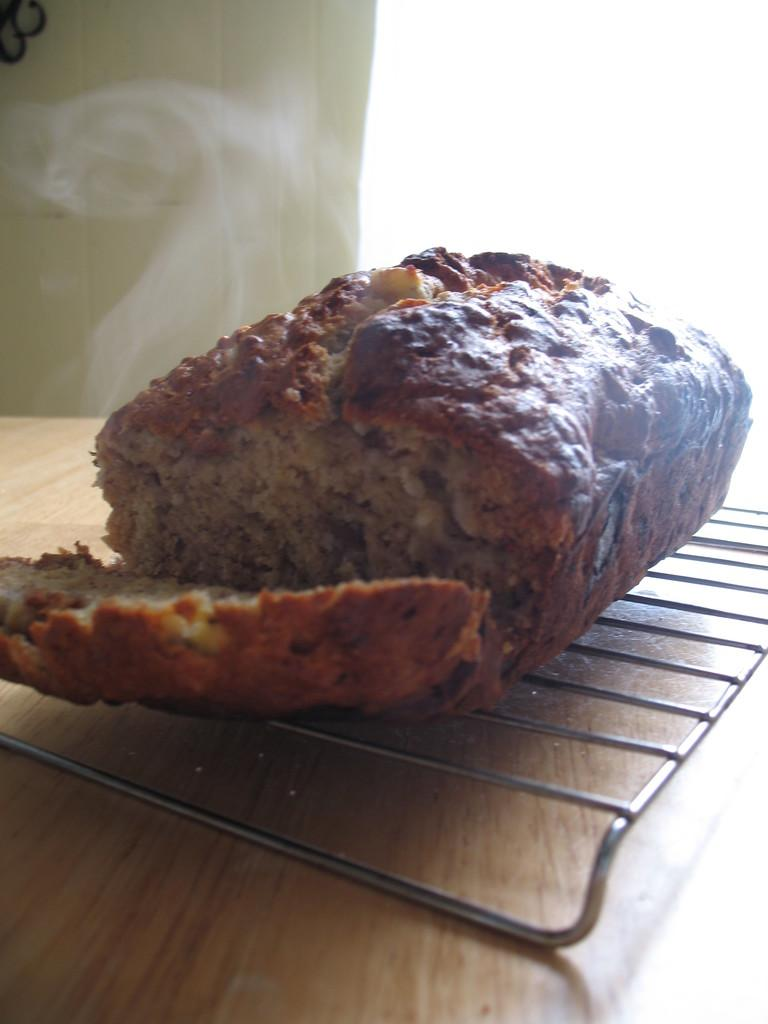What type of surface is visible in the image? There is a wooden surface in the image. What is being cooked on the wooden surface? Food is present on grills in the image. What can be seen in the background of the image? There is a wall in the background of the image. What type of spy equipment can be seen on the wooden surface in the image? There is no spy equipment present in the image; it features a wooden surface with food on grills. What type of collar is visible on the food in the image? There is no collar present on the food in the image; it is simply being cooked on grills. 